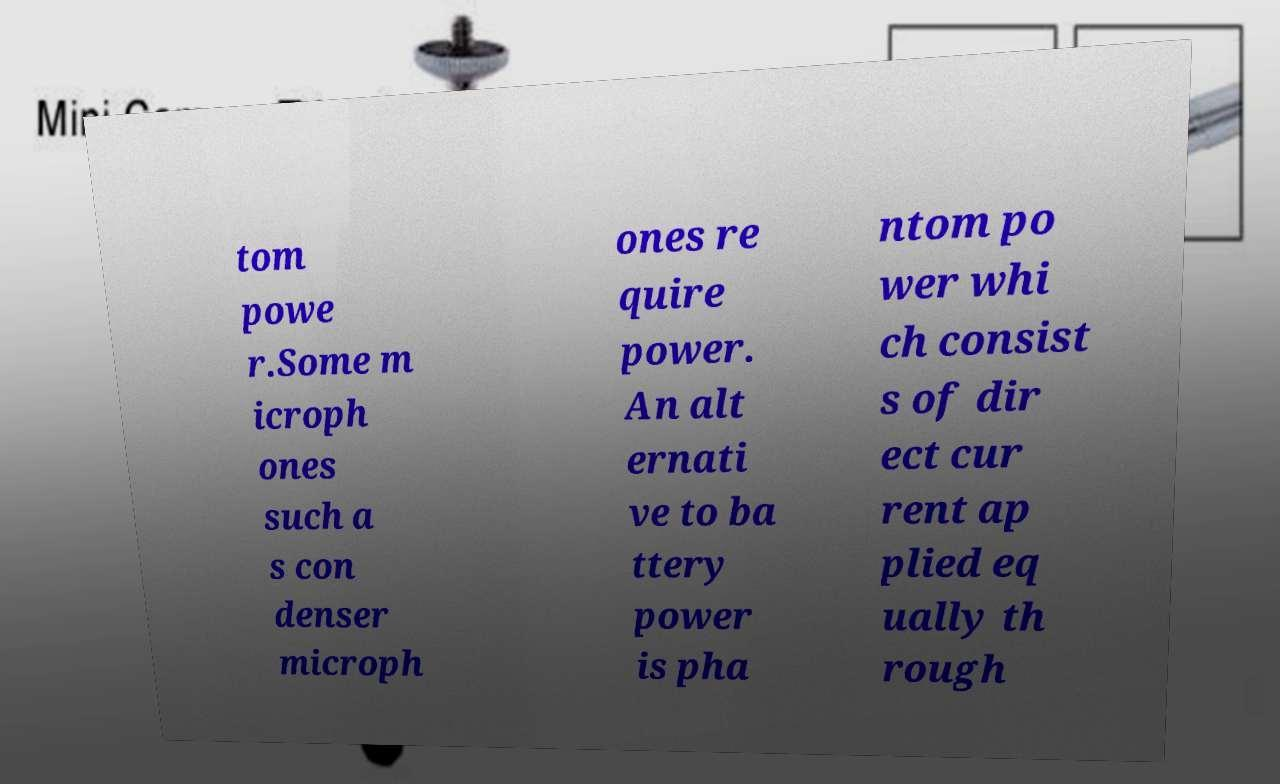Could you assist in decoding the text presented in this image and type it out clearly? tom powe r.Some m icroph ones such a s con denser microph ones re quire power. An alt ernati ve to ba ttery power is pha ntom po wer whi ch consist s of dir ect cur rent ap plied eq ually th rough 